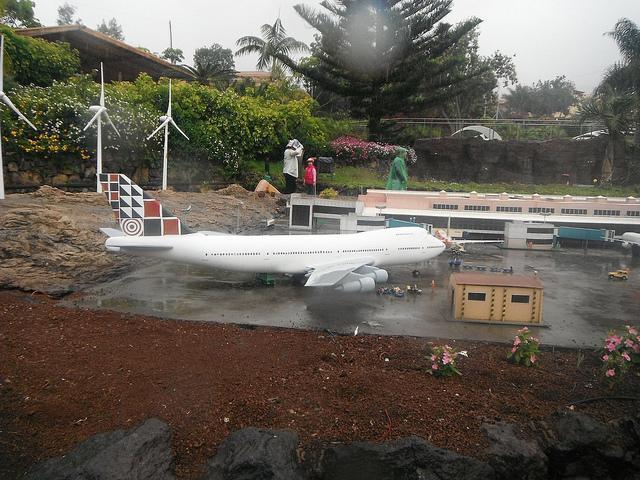How many airplanes can be seen?
Give a very brief answer. 1. How many oranges are in the bowl?
Give a very brief answer. 0. 